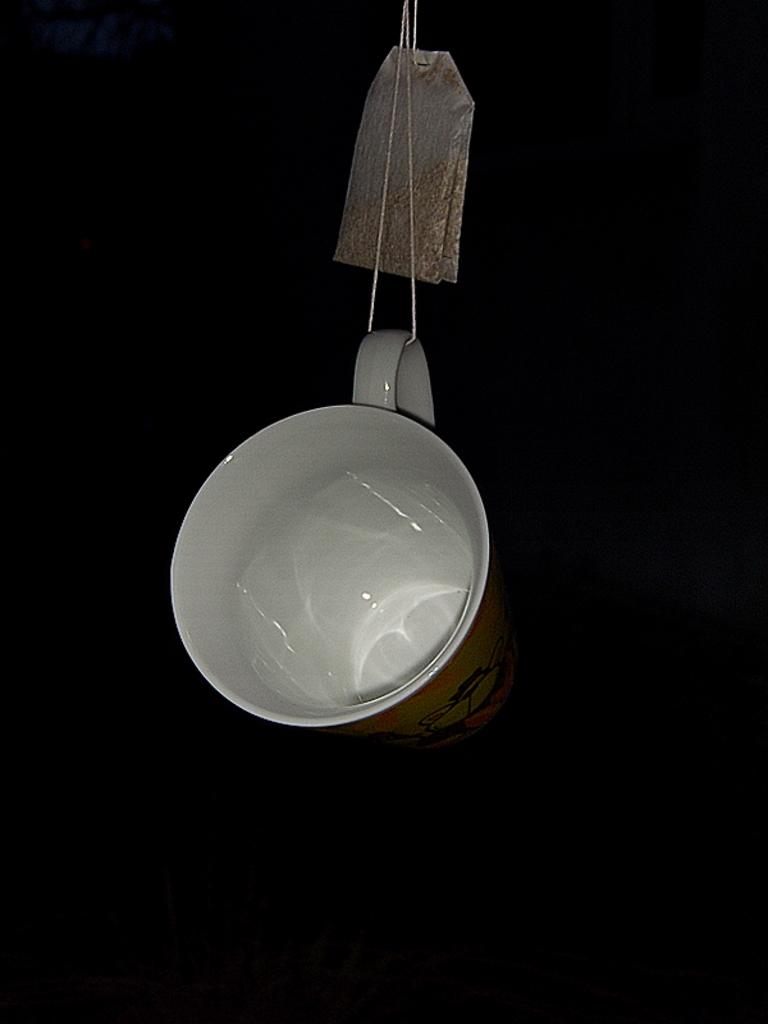What objects are visible in the image? There is a bag and a cup in the image. How are the bag and cup positioned in the image? The bag and cup are hanging on a thread. What can be observed about the background of the image? The background of the image is dark. What type of invention is being demonstrated by the yak in the image? There is no yak present in the image, and therefore no invention being demonstrated. What type of powder is visible in the image? There is no powder visible in the image. 